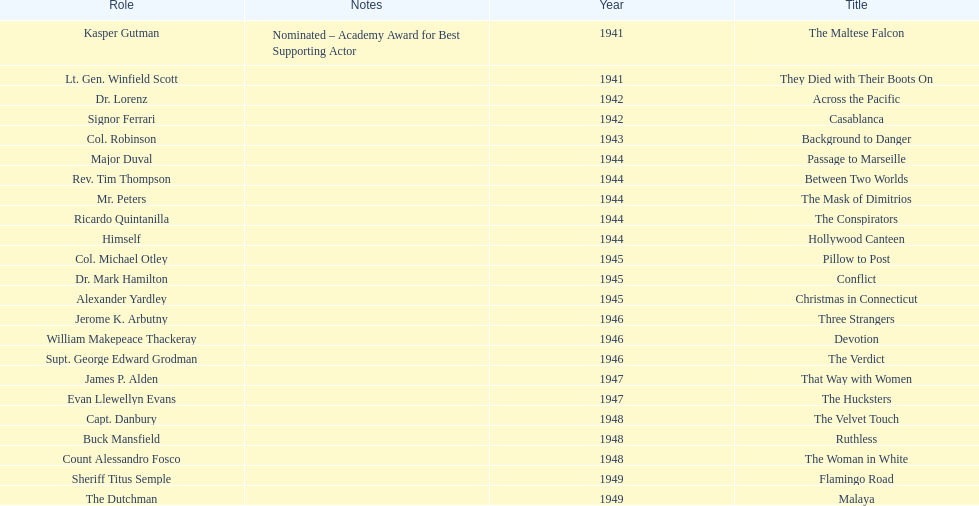What were the first and last movies greenstreet acted in? The Maltese Falcon, Malaya. 